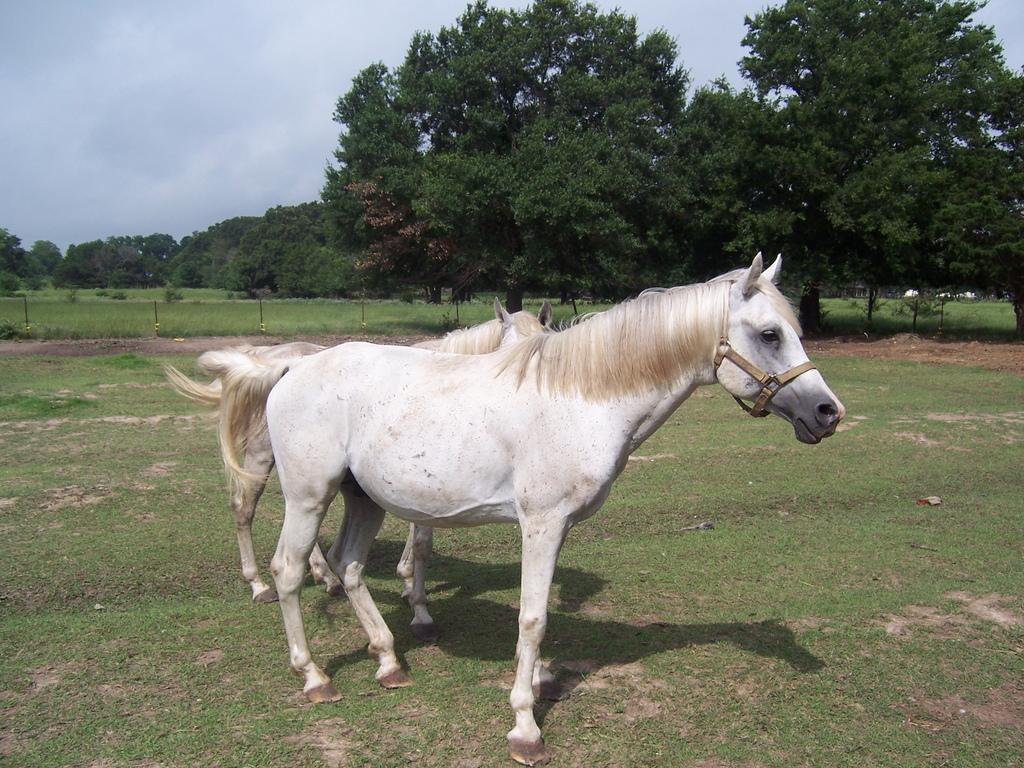In one or two sentences, can you explain what this image depicts? In the center of the image we can see horses on the grass. In the background we can see trees, grass, sky and clouds. 